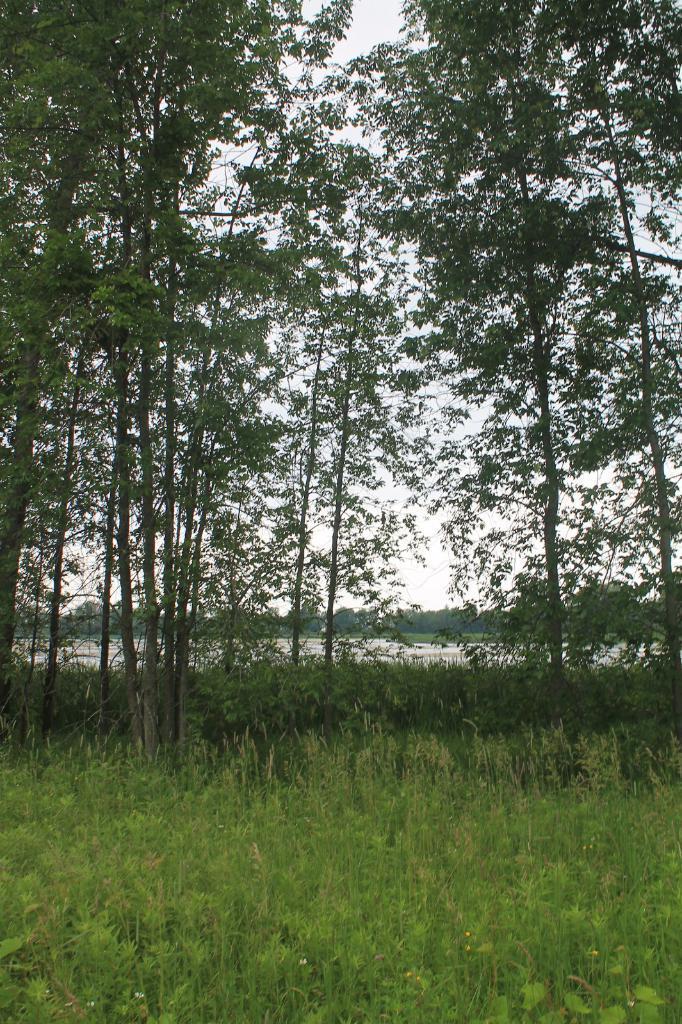How would you summarize this image in a sentence or two? In this picture there is greenery around the area of the image. 